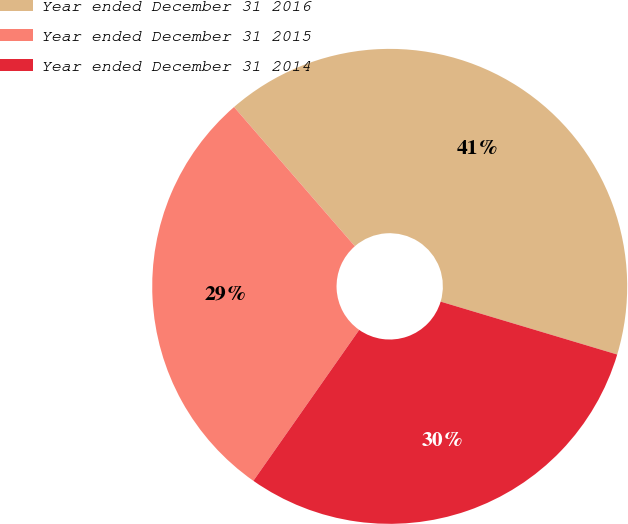Convert chart to OTSL. <chart><loc_0><loc_0><loc_500><loc_500><pie_chart><fcel>Year ended December 31 2016<fcel>Year ended December 31 2015<fcel>Year ended December 31 2014<nl><fcel>41.01%<fcel>28.89%<fcel>30.1%<nl></chart> 